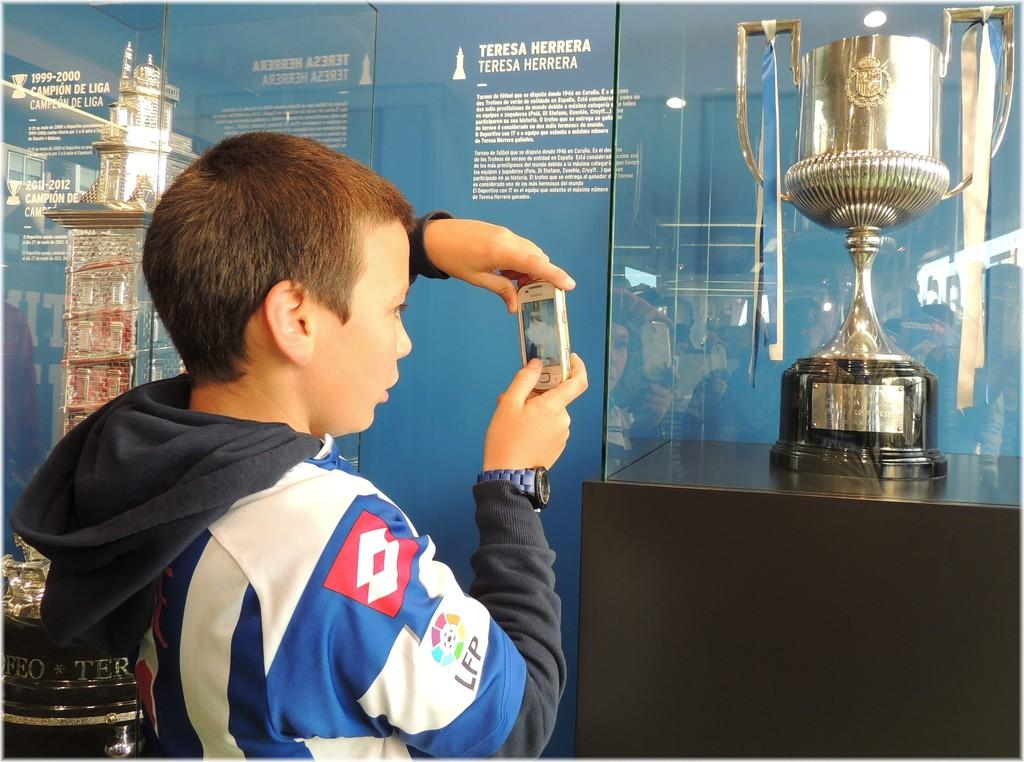Who is the main subject in the image? There is a boy in the image. What is the boy holding in the image? The boy is holding a mobile. What can be seen in the background of the image? There is a banner in the background of the image. What is written or depicted on the banner? There is text on the banner, and there is an award in a glass box on the banner. What type of ray can be seen swimming in the image? There is no ray present in the image; it features a boy holding a mobile and a banner with text and an award. 